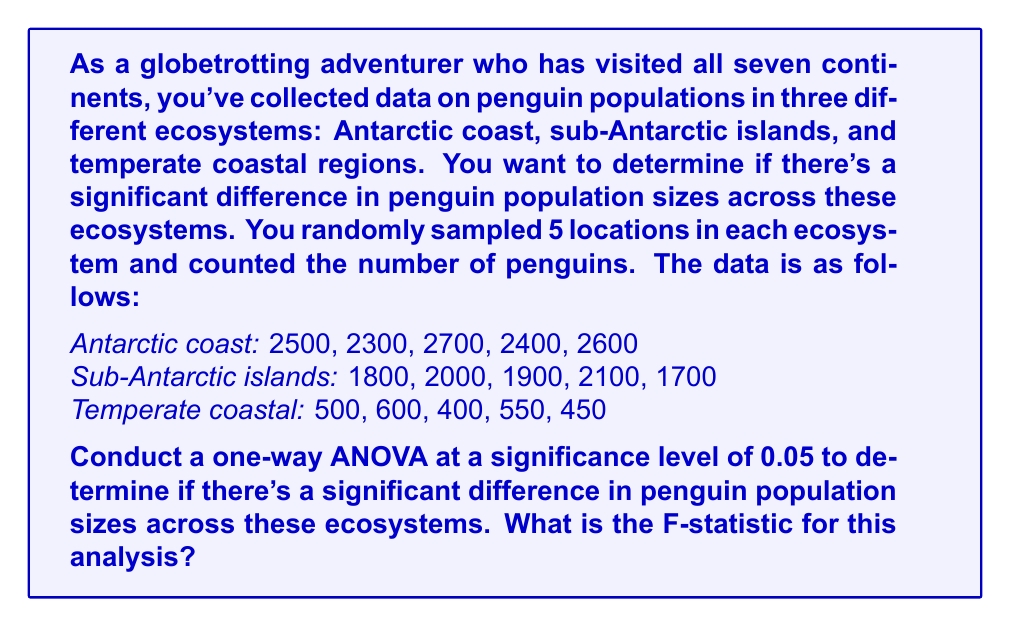What is the answer to this math problem? To conduct a one-way ANOVA, we need to follow these steps:

1. Calculate the sum of squares between groups (SSB)
2. Calculate the sum of squares within groups (SSW)
3. Calculate the total sum of squares (SST)
4. Calculate the degrees of freedom
5. Calculate the mean squares
6. Calculate the F-statistic

Step 1: Calculate the grand mean and group means

Grand mean: $\bar{X} = \frac{2500 + 2300 + ... + 450}{15} = 1633.33$

Group means:
Antarctic coast: $\bar{X}_1 = 2500$
Sub-Antarctic islands: $\bar{X}_2 = 1900$
Temperate coastal: $\bar{X}_3 = 500$

Step 2: Calculate SSB

$$SSB = \sum_{i=1}^{k} n_i(\bar{X}_i - \bar{X})^2$$
$$SSB = 5(2500 - 1633.33)^2 + 5(1900 - 1633.33)^2 + 5(500 - 1633.33)^2$$
$$SSB = 5(866.67)^2 + 5(266.67)^2 + 5(-1133.33)^2$$
$$SSB = 3,755,555.56 + 355,555.56 + 6,422,222.22 = 10,533,333.33$$

Step 3: Calculate SSW

$$SSW = \sum_{i=1}^{k} \sum_{j=1}^{n_i} (X_{ij} - \bar{X}_i)^2$$

For Antarctic coast:
$$(2500 - 2500)^2 + (2300 - 2500)^2 + (2700 - 2500)^2 + (2400 - 2500)^2 + (2600 - 2500)^2 = 160,000$$

For Sub-Antarctic islands:
$$(1800 - 1900)^2 + (2000 - 1900)^2 + (1900 - 1900)^2 + (2100 - 1900)^2 + (1700 - 1900)^2 = 120,000$$

For Temperate coastal:
$$(500 - 500)^2 + (600 - 500)^2 + (400 - 500)^2 + (550 - 500)^2 + (450 - 500)^2 = 40,000$$

$$SSW = 160,000 + 120,000 + 40,000 = 320,000$$

Step 4: Calculate degrees of freedom

Between groups: $df_B = k - 1 = 3 - 1 = 2$
Within groups: $df_W = N - k = 15 - 3 = 12$
Total: $df_T = N - 1 = 15 - 1 = 14$

Step 5: Calculate mean squares

$$MSB = \frac{SSB}{df_B} = \frac{10,533,333.33}{2} = 5,266,666.67$$
$$MSW = \frac{SSW}{df_W} = \frac{320,000}{12} = 26,666.67$$

Step 6: Calculate F-statistic

$$F = \frac{MSB}{MSW} = \frac{5,266,666.67}{26,666.67} = 197.5$$
Answer: The F-statistic for this one-way ANOVA is 197.5. 